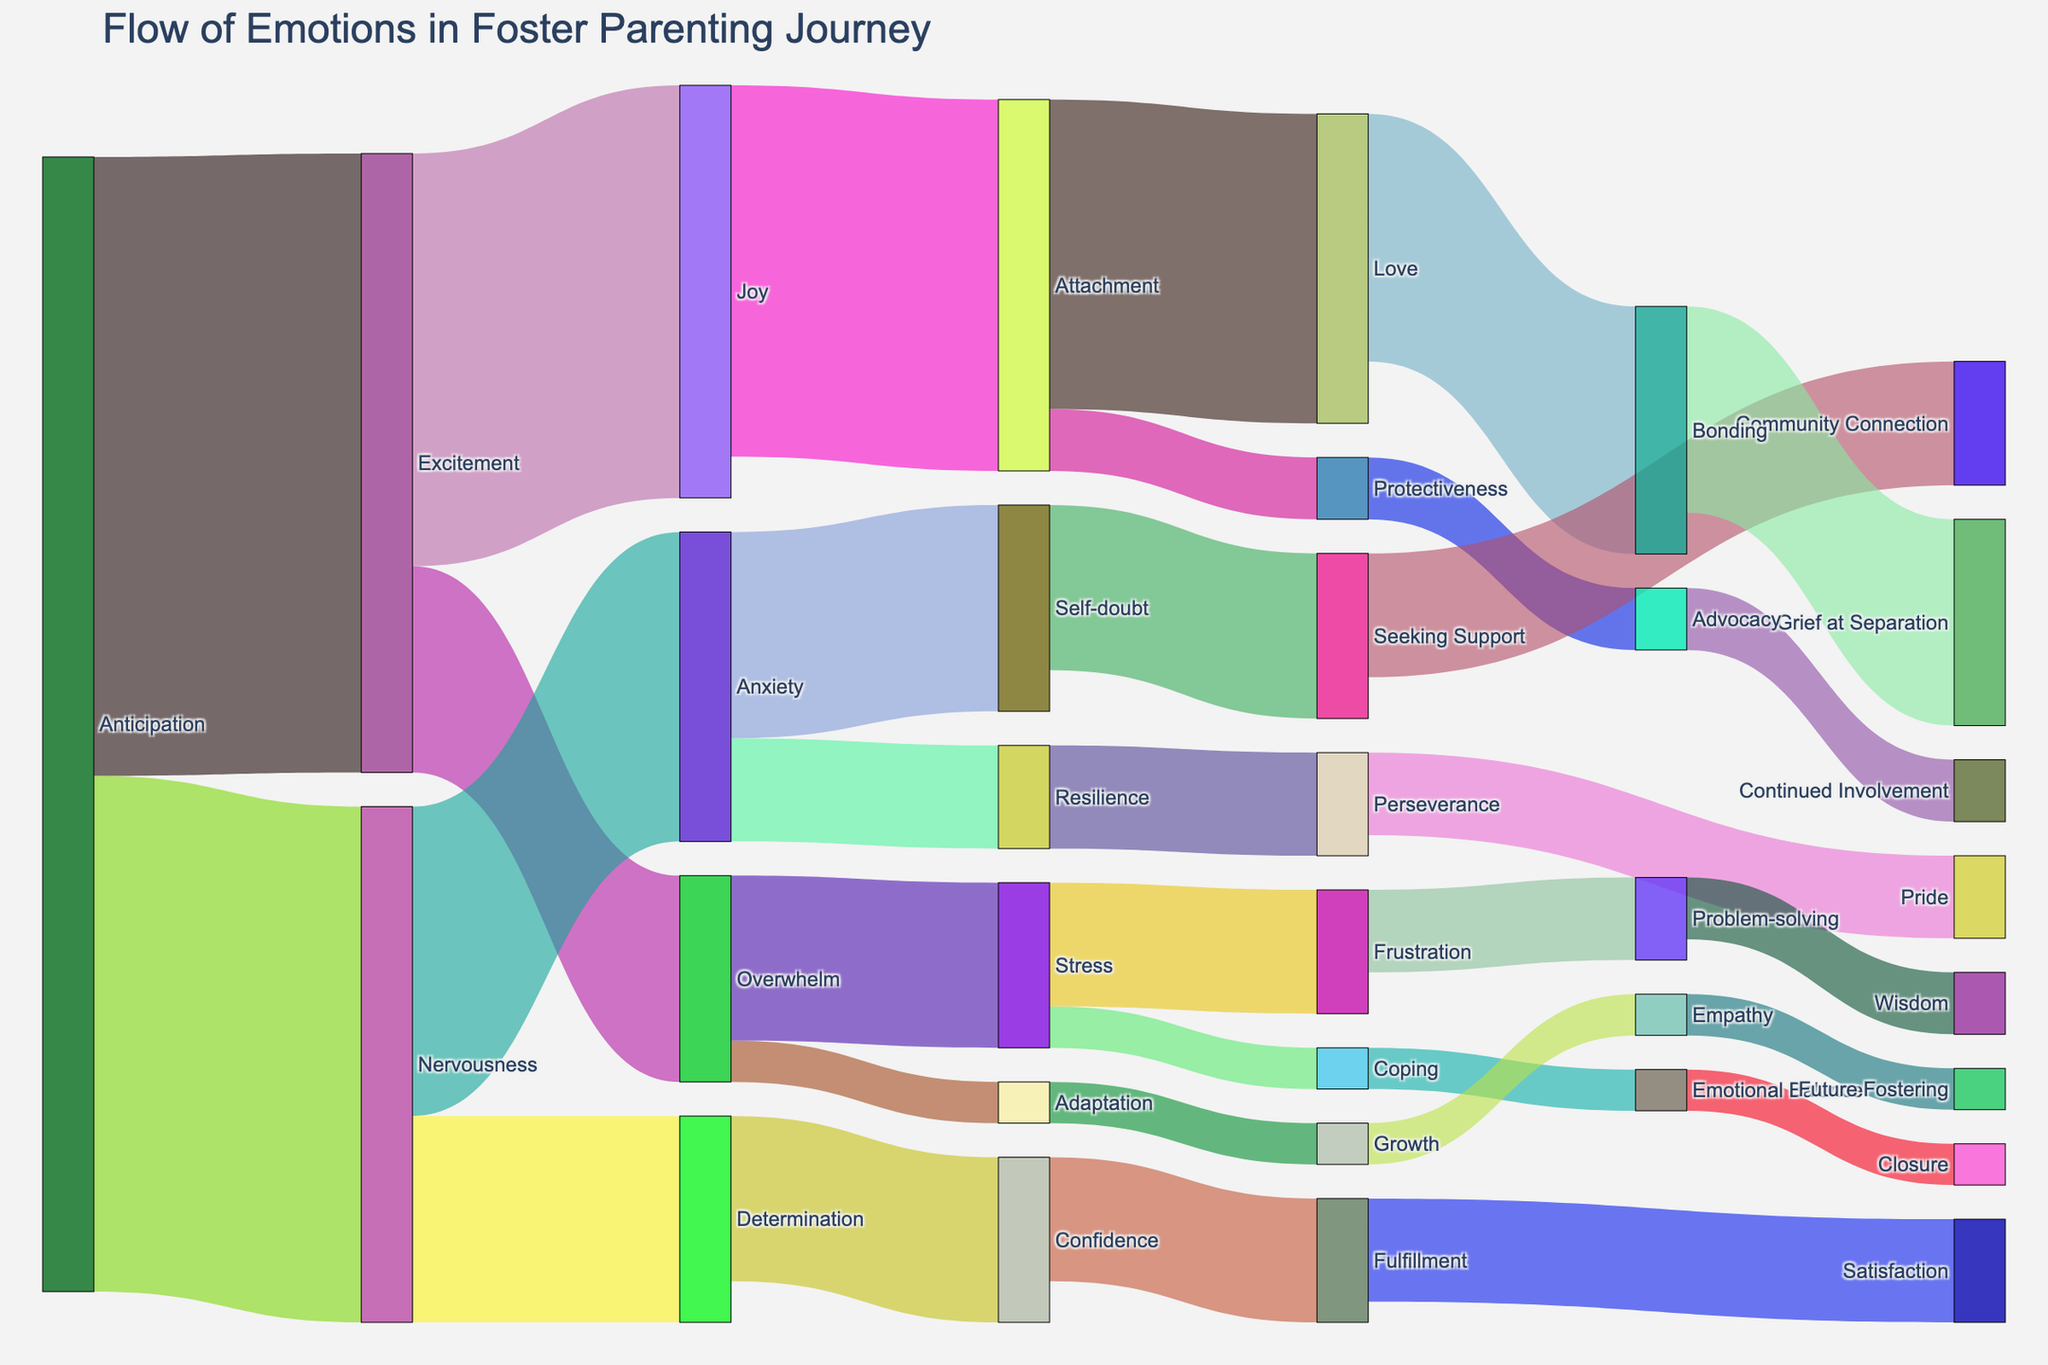What's the main emotion experienced during the anticipation phase? The anticipation phase flows into excitement and nervousness. The flow value associated with excitement is higher (30) than that of nervousness (25).
Answer: Excitement From anticipation, which emotion has a higher flow value, nervousness or excitement? By looking at the thickness of the flows from anticipation, we see that the value for excitement is higher (30) compared to nervousness (25).
Answer: Excitement Which emotions does excitement lead into, and what are their corresponding flow values? Excitement leads into joy with a flow value of 20, and overwhelm with a flow value of 10.
Answer: Joy (20), Overwhelm (10) What is the final flow value for love from the anticipation phase? Anticipation flows into excitement and nervousness. Excitement leads to joy, which then flows into attachment, and ultimately leads to love with a flow value of 15.
Answer: 15 How many total flows come out of nervousness, and what are their values? Nervousness flows into anxiety with a value of 15 and determination with a value of 10.
Answer: 2 flows, values are 15 and 10 Which emotion has the highest single flow value in the entire diagram? By scanning through all the flow values in the diagram, the highest value is 30, which is the flow from anticipation to excitement.
Answer: Excitement (30) Compare the flow values of joy and stress outcomes – which has a greater combined value? Joy flows into attachment (18) and stress flows into frustration (6) and coping (2). The combined value for attachment is 18, and for stress outcomes it is 8.
Answer: Joy outcomes (18) Which emotion in the closure phase is directly linked, and what's its flow value? Emotional balance connects directly to closure with a flow value of 2, indicating a path leading to closure.
Answer: Closure (2) How does the flow from overwhelm diverge, and what are the associated emotions and values? Overwhelm flows into stress (with a value of 8) and adaptation (with a value of 2).
Answer: Stress (8), Adaptation (2) 